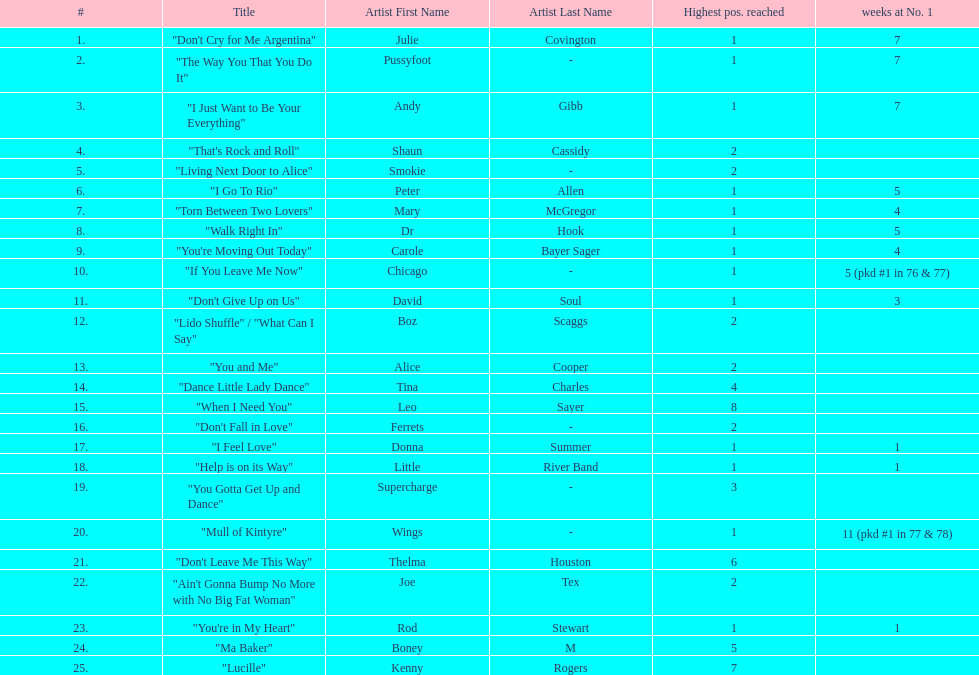What was the number of weeks that julie covington's single " don't cry for me argentinia," was at number 1 in 1977? 7. 